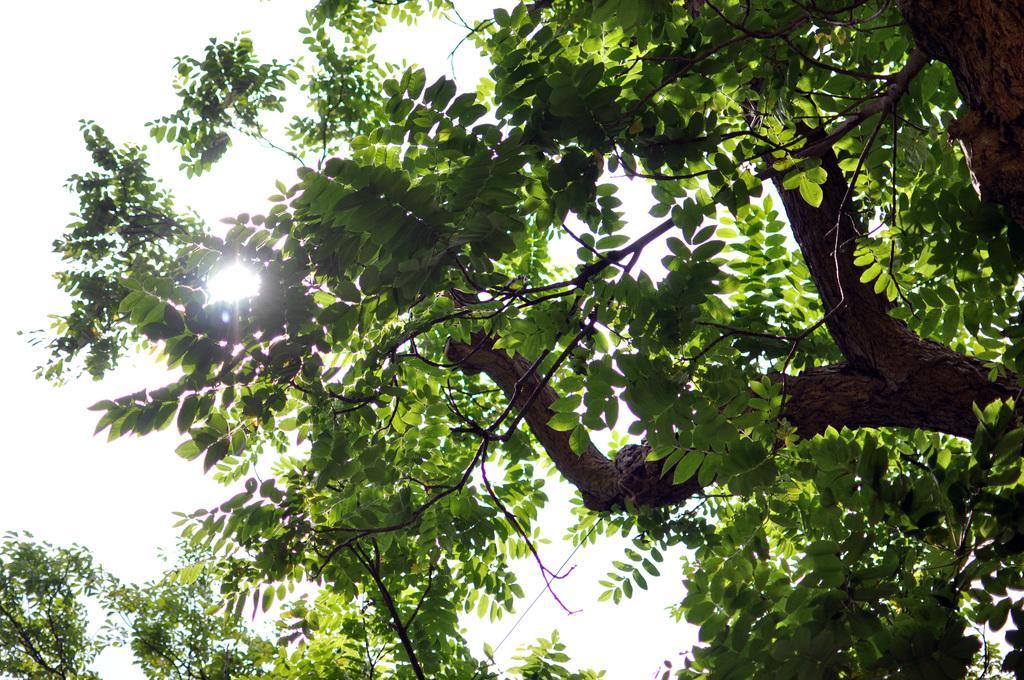How would you summarize this image in a sentence or two? In this image we can see a tree on which there are some leaves and in the background of the image there is clear sky. 